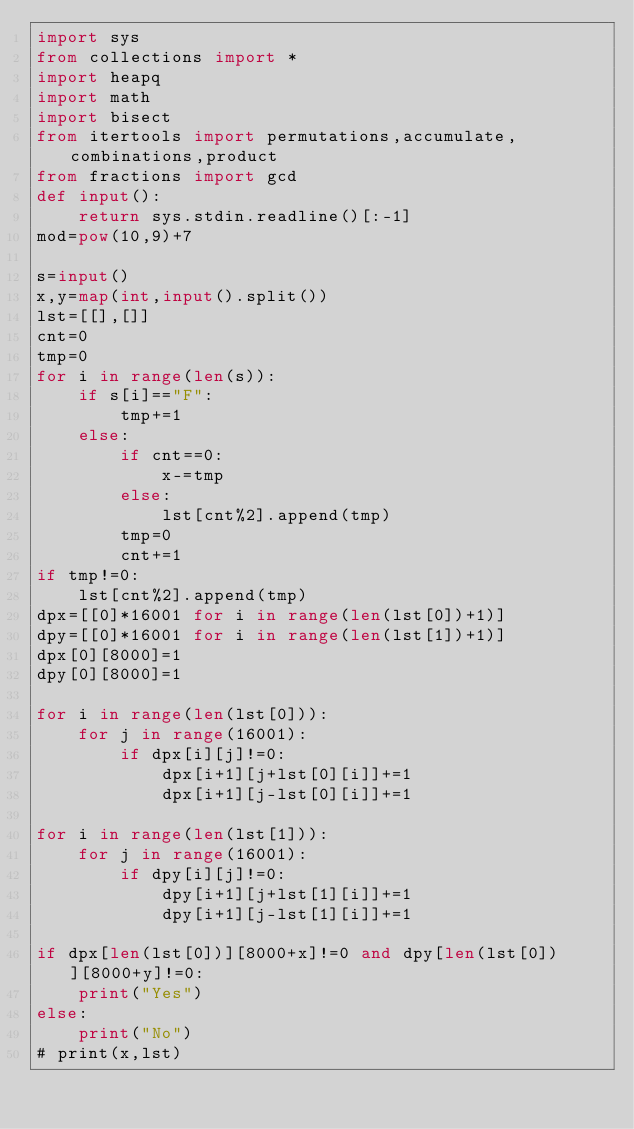<code> <loc_0><loc_0><loc_500><loc_500><_Python_>import sys
from collections import *
import heapq
import math
import bisect
from itertools import permutations,accumulate,combinations,product
from fractions import gcd
def input():
    return sys.stdin.readline()[:-1]
mod=pow(10,9)+7

s=input()
x,y=map(int,input().split())
lst=[[],[]]
cnt=0
tmp=0
for i in range(len(s)):
    if s[i]=="F":
        tmp+=1
    else:
        if cnt==0:
            x-=tmp
        else:
            lst[cnt%2].append(tmp)
        tmp=0
        cnt+=1
if tmp!=0:
    lst[cnt%2].append(tmp)
dpx=[[0]*16001 for i in range(len(lst[0])+1)]
dpy=[[0]*16001 for i in range(len(lst[1])+1)]
dpx[0][8000]=1
dpy[0][8000]=1

for i in range(len(lst[0])):
    for j in range(16001):
        if dpx[i][j]!=0:
            dpx[i+1][j+lst[0][i]]+=1
            dpx[i+1][j-lst[0][i]]+=1

for i in range(len(lst[1])):
    for j in range(16001):
        if dpy[i][j]!=0:
            dpy[i+1][j+lst[1][i]]+=1
            dpy[i+1][j-lst[1][i]]+=1

if dpx[len(lst[0])][8000+x]!=0 and dpy[len(lst[0])][8000+y]!=0:
    print("Yes")
else:
    print("No")
# print(x,lst)</code> 